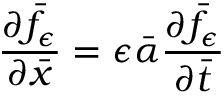Convert formula to latex. <formula><loc_0><loc_0><loc_500><loc_500>\frac { \partial \bar { f } _ { \epsilon } } { \partial \bar { x } } = \epsilon \bar { \alpha } \frac { \partial \bar { f } _ { \epsilon } } { \partial \bar { t } }</formula> 